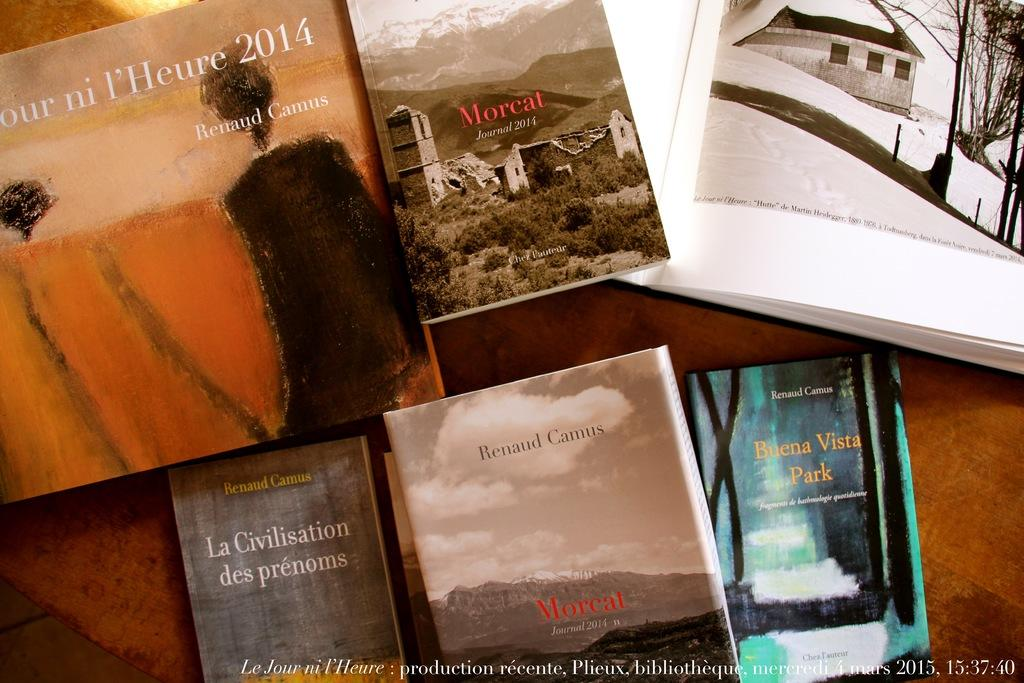<image>
Render a clear and concise summary of the photo. A book called Morcat Journal 2014 is next to a book by Renaud Camus. 